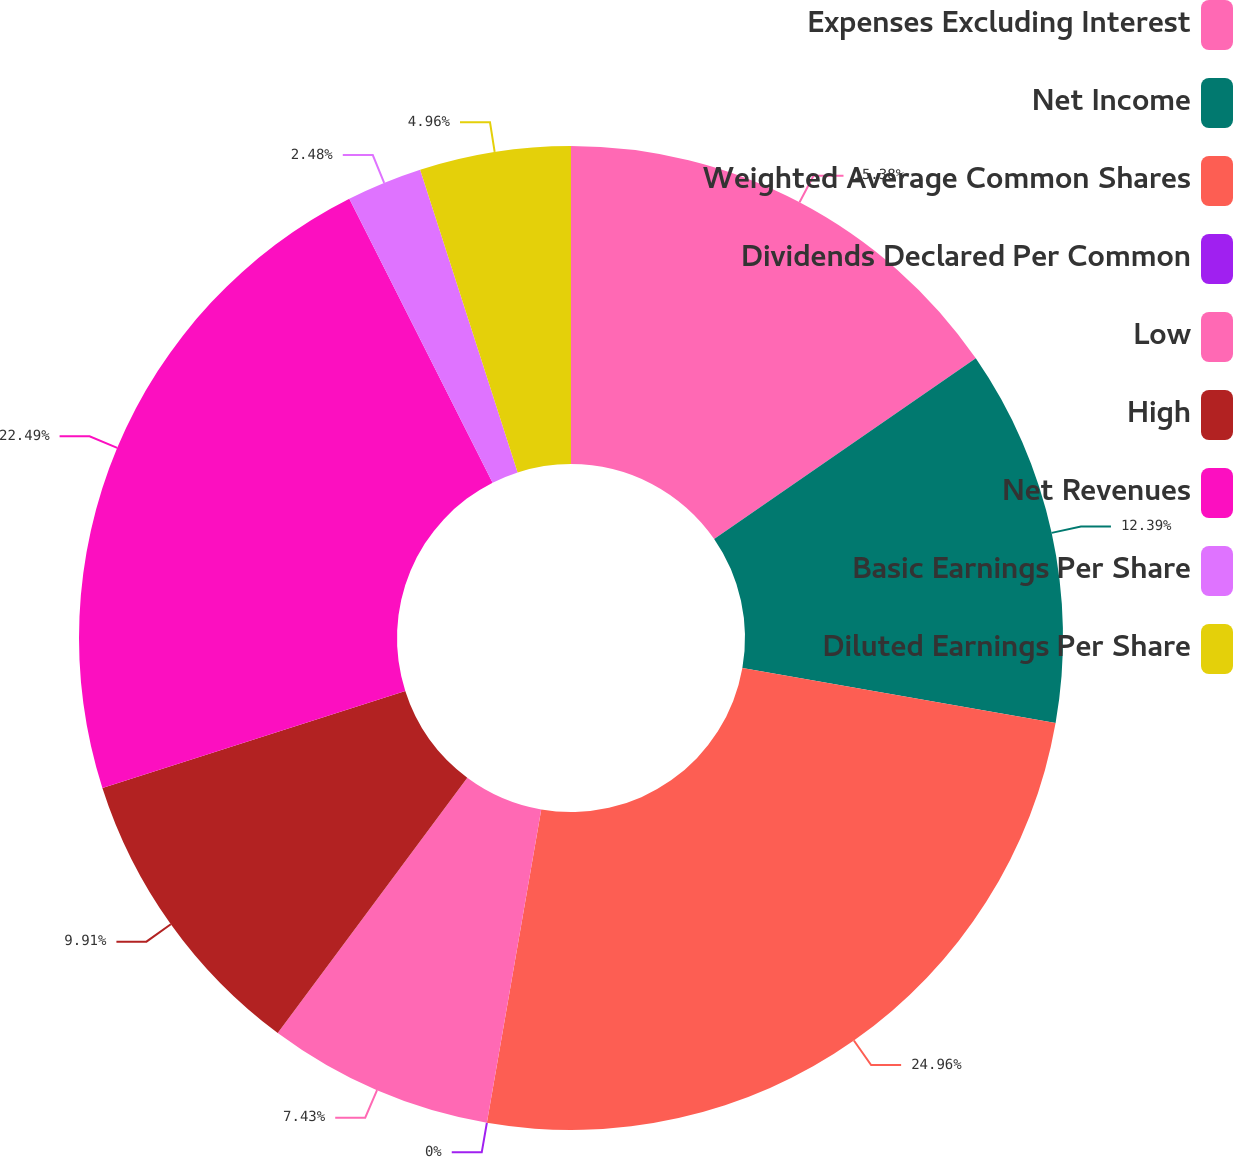Convert chart to OTSL. <chart><loc_0><loc_0><loc_500><loc_500><pie_chart><fcel>Expenses Excluding Interest<fcel>Net Income<fcel>Weighted Average Common Shares<fcel>Dividends Declared Per Common<fcel>Low<fcel>High<fcel>Net Revenues<fcel>Basic Earnings Per Share<fcel>Diluted Earnings Per Share<nl><fcel>15.38%<fcel>12.39%<fcel>24.97%<fcel>0.0%<fcel>7.43%<fcel>9.91%<fcel>22.49%<fcel>2.48%<fcel>4.96%<nl></chart> 